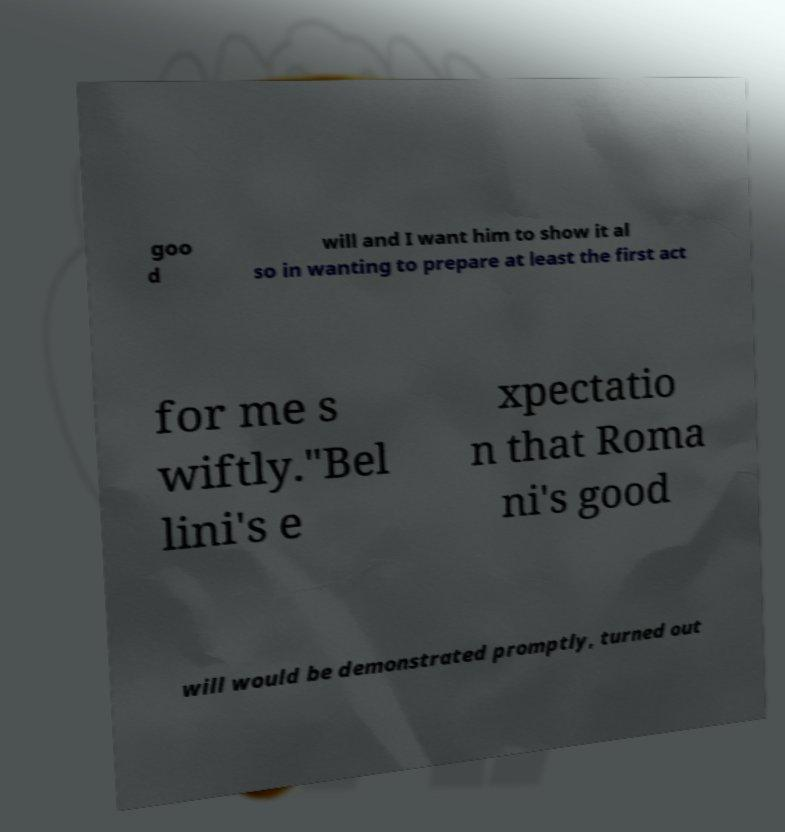Could you assist in decoding the text presented in this image and type it out clearly? goo d will and I want him to show it al so in wanting to prepare at least the first act for me s wiftly."Bel lini's e xpectatio n that Roma ni's good will would be demonstrated promptly, turned out 